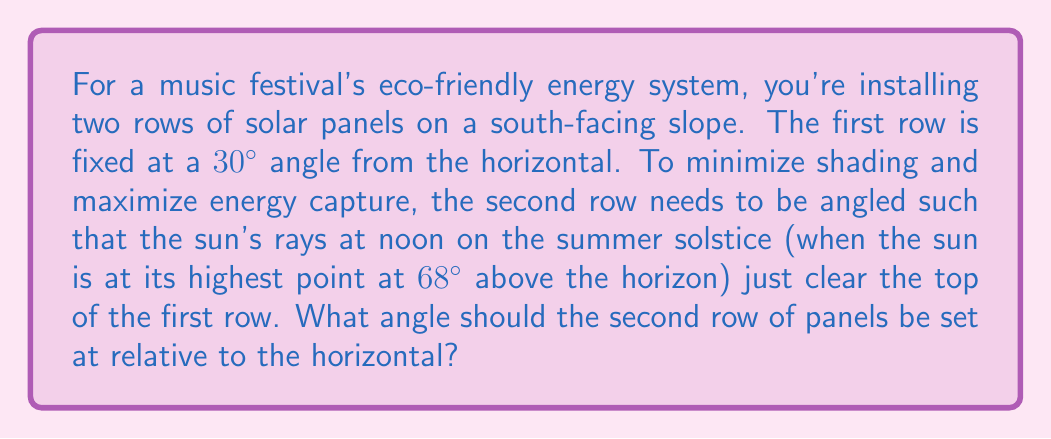Solve this math problem. Let's approach this step-by-step:

1) First, let's visualize the problem:

[asy]
import geometry;

size(200);

pair A = (0,0), B = (5,0), C = (5,2.89), D = (1.67,2.89);
pair E = (6.67,0), F = (6.67,3.85);

draw(A--B--C--D--A);
draw(B--E--F--C);

label("30°", (0.5,0.3), E);
label("x°", (6.2,0.3), E);
label("68°", (5.5,3.2), NW);

draw((-1,0)--(7,0), arrow=Arrow(TeXHead));
draw((5,0)--(5,4), arrow=Arrow(TeXHead));

label("Horizontal", (3,-0.3), S);
label("Vertical", (5.3,2), E);
[/asy]

2) We need to find the angle x° that the second row should be set at.

3) The key is to realize that the line representing the sun's rays (at 68° to the horizontal) should just touch the top of the first panel and the bottom of the second panel.

4) This creates two right-angled triangles that share a common angle (the one we're looking for).

5) In the first triangle (the one with the 30° angle):
   $$\tan(30°) = \frac{\text{opposite}}{\text{adjacent}}$$

6) In the second triangle (the one with the 68° angle):
   $$\tan(68°) = \frac{\text{opposite} + \text{height of first panel}}{\text{adjacent}}$$

7) The "opposite" and "adjacent" in step 5 are the height and width of the first panel. Let's call the width 1 unit for simplicity. Then:
   $$\tan(30°) = \frac{\text{height}}{1}$$
   $$\text{height} = \tan(30°) \approx 0.577$$

8) Now we can use this in the equation from step 6:
   $$\tan(68°) = \frac{x + 0.577}{1}$$
   Where x is the height of the second panel.

9) Solving for x:
   $$x = \tan(68°) - 0.577 \approx 1.697$$

10) Now we have the height and width of the second panel's right triangle. We can find the angle:
    $$\tan(x°) = \frac{1.697}{1} = 1.697$$
    $$x° = \arctan(1.697) \approx 59.5°$$

Therefore, the second row of panels should be set at approximately 59.5° to the horizontal.
Answer: 59.5° 